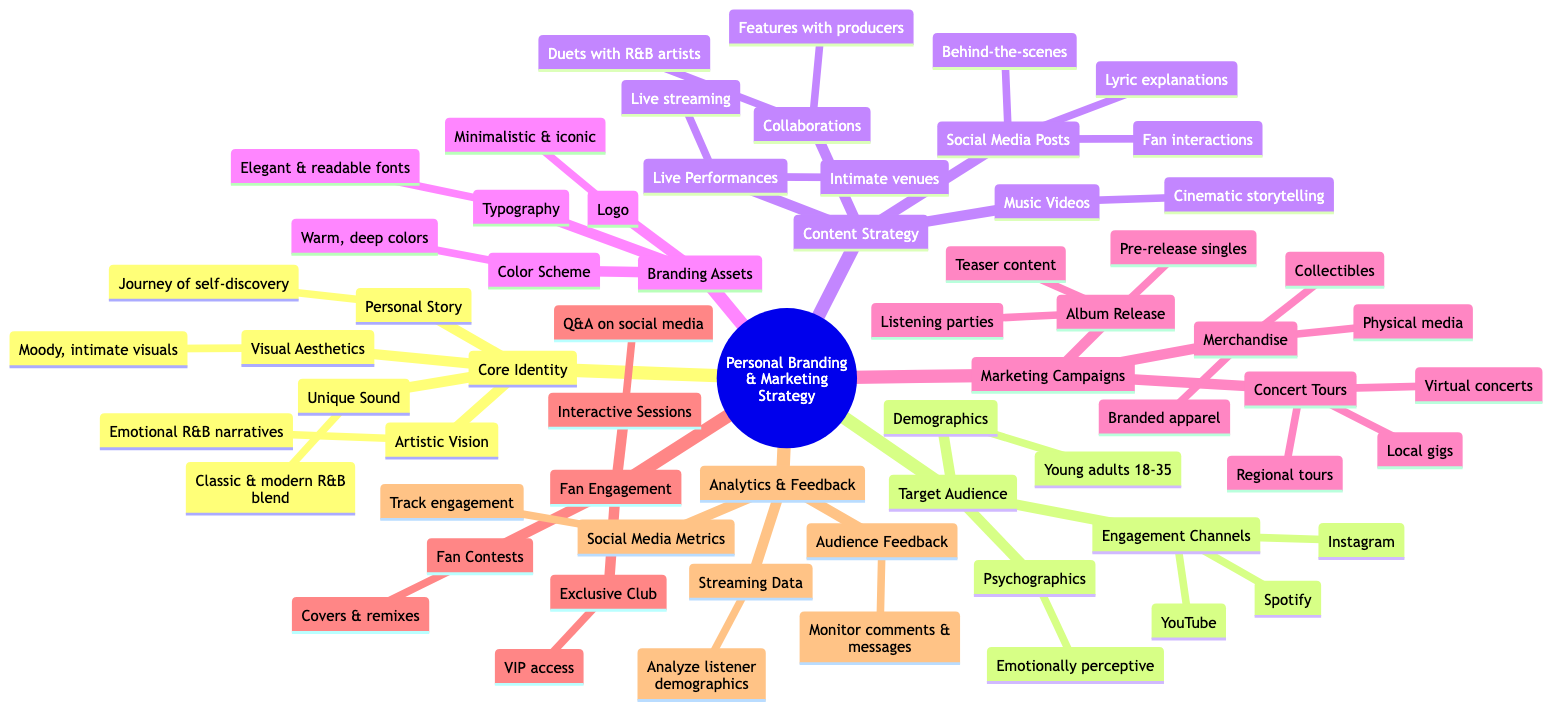What is the unique sound described in the diagram? The diagram explicitly states that the unique sound is a blend of classic and modern R&B with soulful vocals. This is directly referenced under the "Unique Sound" node.
Answer: Blend of classic and modern R&B with soulful vocals How many engagement channels are mentioned? The "Engagement Channels" node lists three specific platforms: Instagram, YouTube, and Spotify. Therefore, there are three engagement channels listed.
Answer: 3 What type of content is included in the content strategy for music videos? Under the "Music Videos" node within the "Content Strategy," it specifies high-quality storytelling music videos with cinematic appeal. This is the key detail about the type of content aimed in this category.
Answer: High-quality storytelling music videos with cinematic appeal What are the age demographics of the target audience? The "Demographics" node under "Target Audience" clearly states that the target audience consists of young adults aged 18-35. This is a specific piece of data provided in the diagram.
Answer: Young adults aged 18-35 What is a key component of the fan engagement strategy? The "Fan Engagement" section mentions an exclusive club providing VIP access as a key component, which reflects the intent to foster closer interactions and loyalty among fans. This detail is underlined in the exclusive club node.
Answer: VIP fan club with early access How do the marketing campaigns for concert tours enhance reach? The "Concert Tours" node outlines three strategies: local gigs, regional tours, and virtual concerts. These methods collectively enhance reach by creating grassroots support, expanding geographically, and engaging through virtual platforms, thus broadening the audience base effectively.
Answer: Local gigs, regional tours, virtual concerts What visual aesthetics does the branding emphasize? The "Visual Aesthetics" node notes that the branding focuses on moody, intimate visuals that reflect deep emotions. This description highlights the emotional tone sought through the visual branding strategy.
Answer: Moody, intimate visuals reflecting deep emotions What types of merchandise are included in the marketing campaigns? The "Merchandise" node falls under "Marketing Campaigns" and details three categories: branded apparel, physical media, and collectibles. Thus, it offers a structured outline of the merchandise types available.
Answer: Branded apparel, physical media, collectibles 